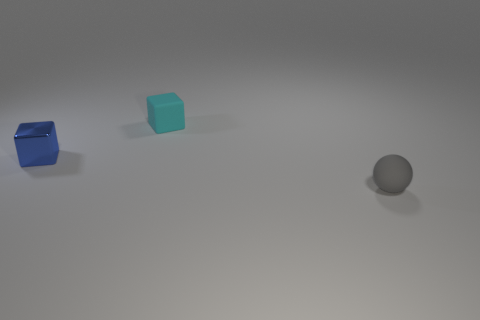Add 3 tiny cyan rubber cubes. How many objects exist? 6 Subtract all spheres. How many objects are left? 2 Add 1 small gray balls. How many small gray balls exist? 2 Subtract 0 green cylinders. How many objects are left? 3 Subtract all large purple metallic blocks. Subtract all metallic objects. How many objects are left? 2 Add 1 balls. How many balls are left? 2 